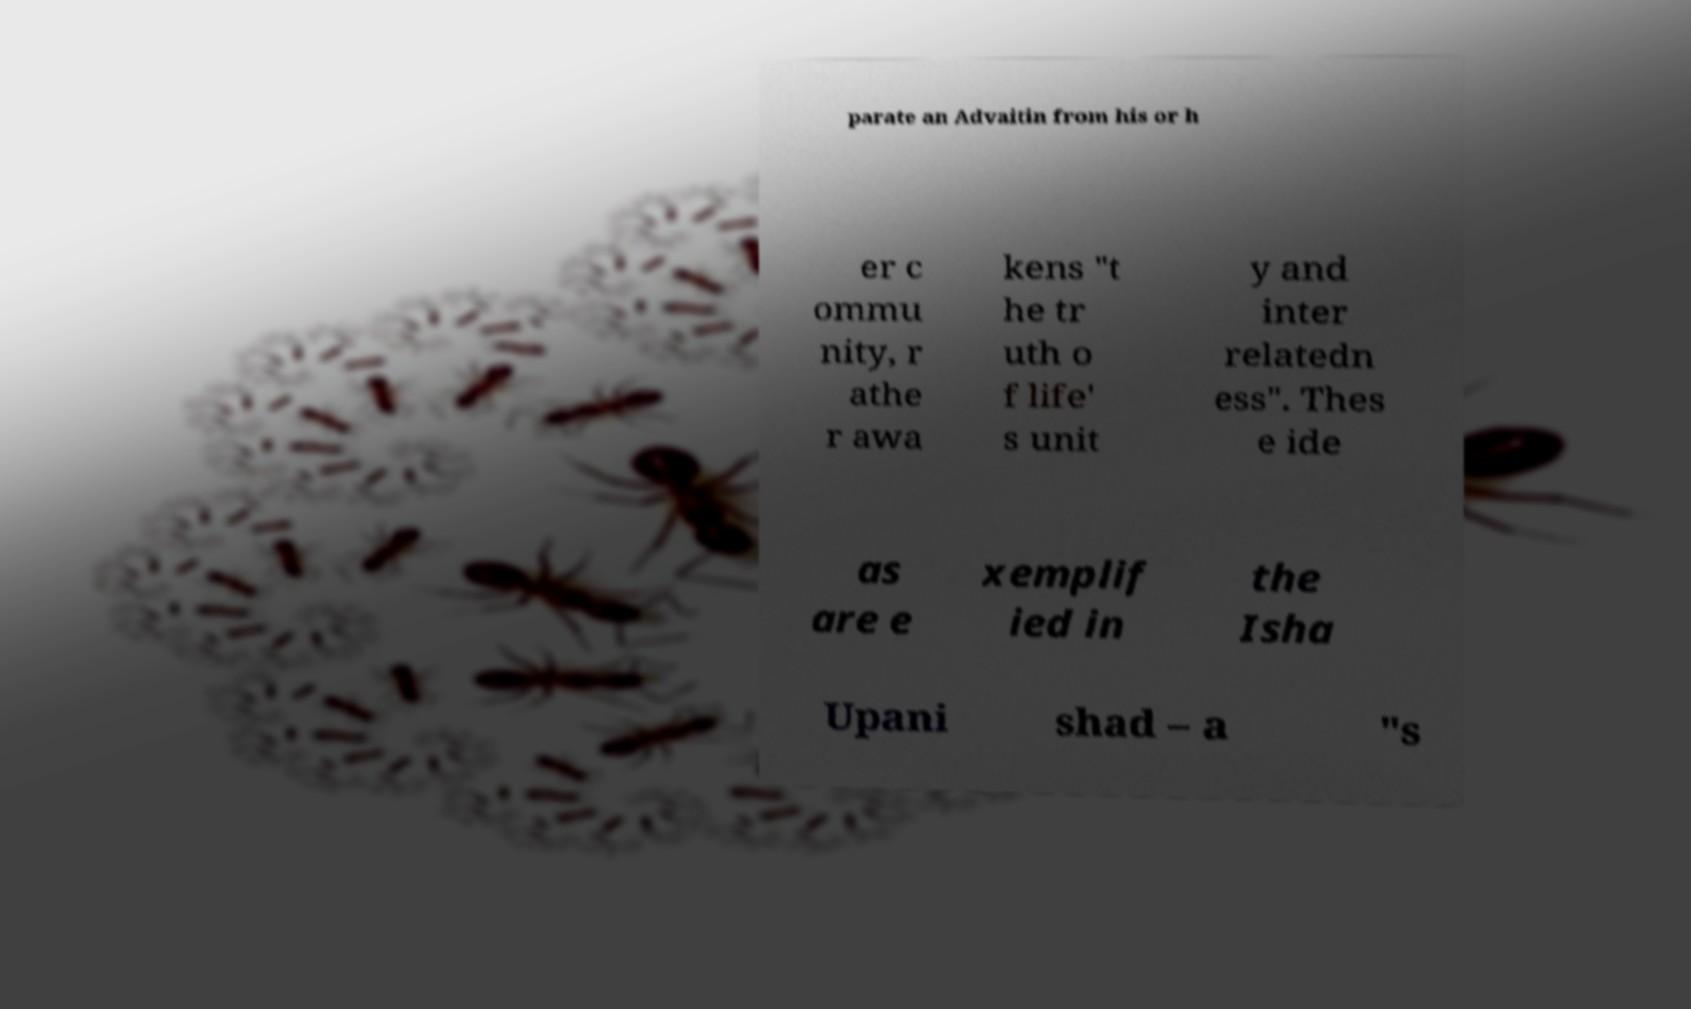What messages or text are displayed in this image? I need them in a readable, typed format. parate an Advaitin from his or h er c ommu nity, r athe r awa kens "t he tr uth o f life' s unit y and inter relatedn ess". Thes e ide as are e xemplif ied in the Isha Upani shad – a "s 